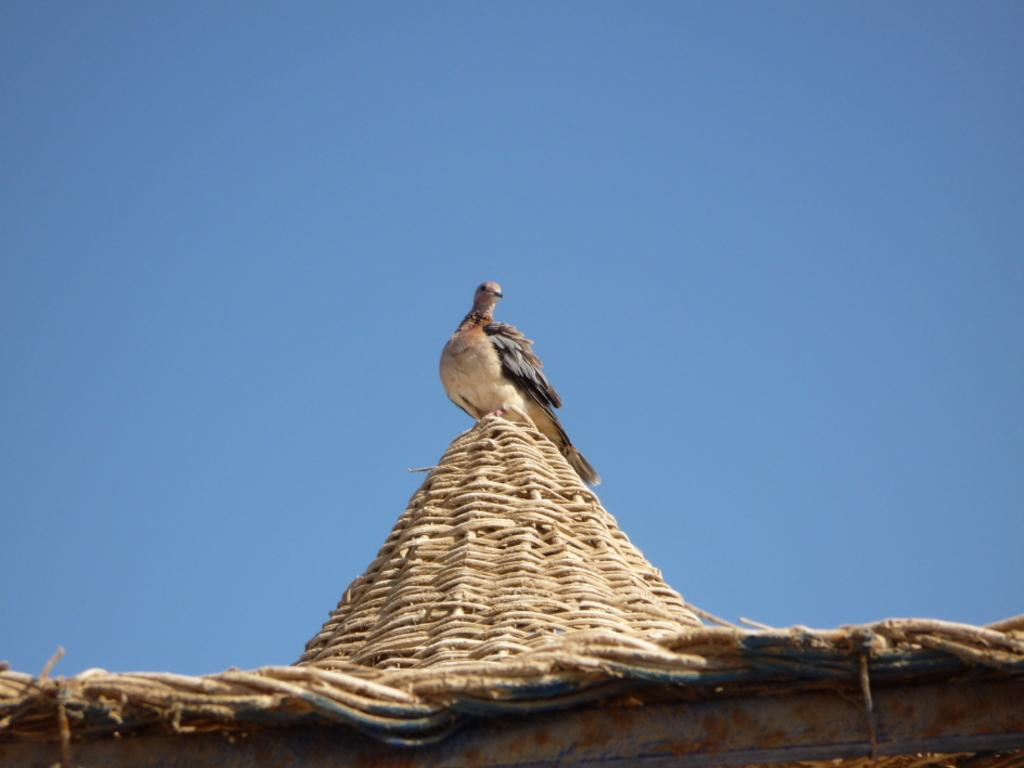What can be seen at the top of the image? The sky is visible towards the top of the image. What is located at the bottom of the image? There is a roof towards the bottom of the image. Is there any wildlife present in the image? Yes, there is a bird on the roof. Can you see the toes of the bird in the image? There is no indication of the bird's toes being visible in the image. Is there a crown on the bird's head in the image? There is no crown present on the bird's head in the image. 